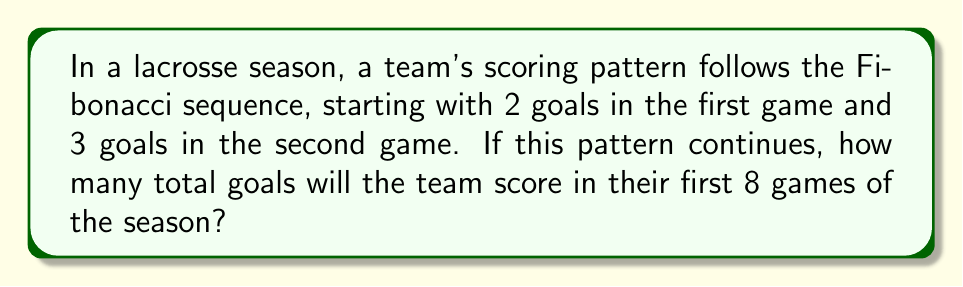Could you help me with this problem? Let's approach this step-by-step:

1) First, recall the Fibonacci sequence: Each number is the sum of the two preceding ones. In this case, we start with 2 and 3.

2) Let's list out the goals scored in each game:
   Game 1: 2 goals
   Game 2: 3 goals
   Game 3: 2 + 3 = 5 goals
   Game 4: 3 + 5 = 8 goals
   Game 5: 5 + 8 = 13 goals
   Game 6: 8 + 13 = 21 goals
   Game 7: 13 + 21 = 34 goals
   Game 8: 21 + 34 = 55 goals

3) Now, we need to sum all these goals:

   $$ \text{Total Goals} = 2 + 3 + 5 + 8 + 13 + 21 + 34 + 55 $$

4) Adding these numbers:

   $$ \text{Total Goals} = 141 $$

Therefore, the team will score a total of 141 goals in their first 8 games if they follow this Fibonacci-based scoring pattern.
Answer: 141 goals 